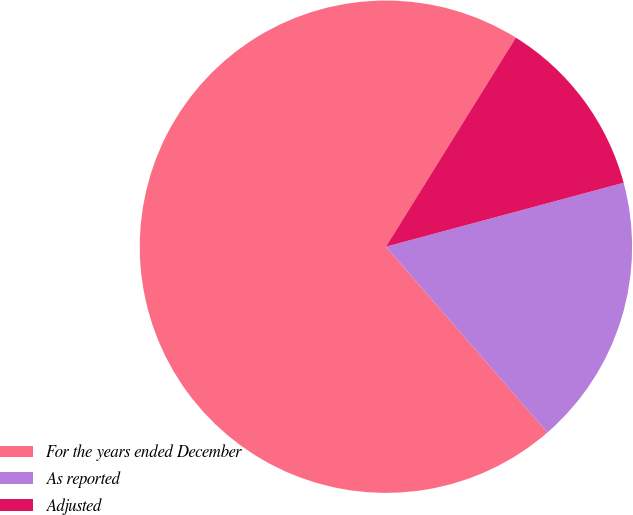<chart> <loc_0><loc_0><loc_500><loc_500><pie_chart><fcel>For the years ended December<fcel>As reported<fcel>Adjusted<nl><fcel>70.24%<fcel>17.79%<fcel>11.97%<nl></chart> 